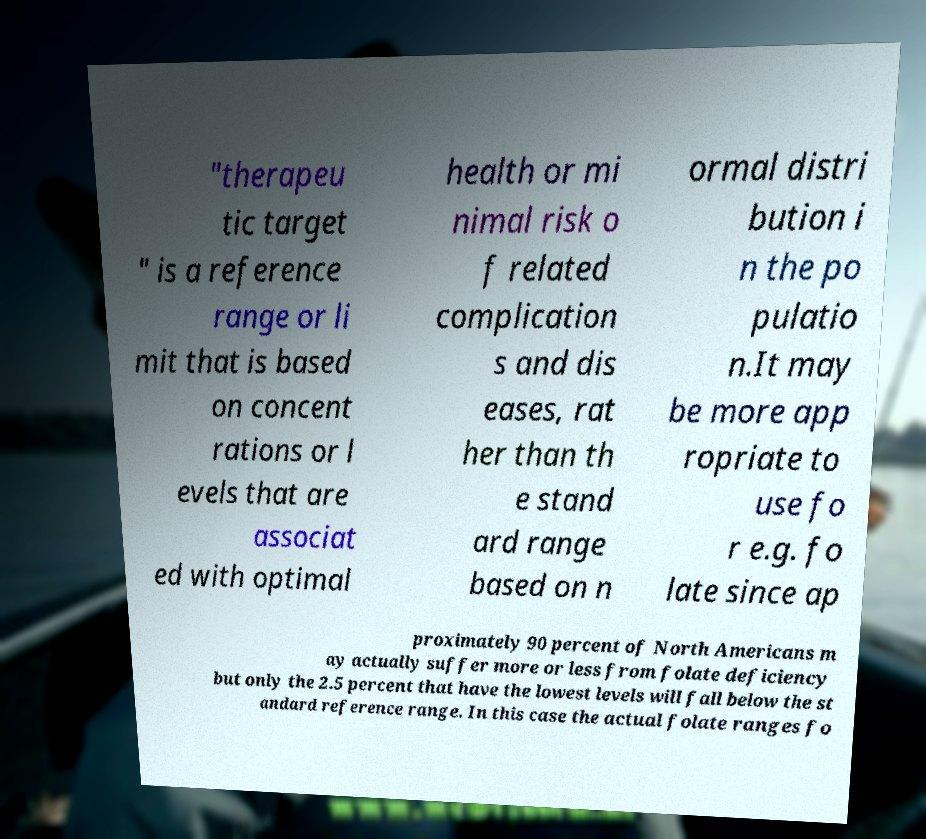Could you assist in decoding the text presented in this image and type it out clearly? "therapeu tic target " is a reference range or li mit that is based on concent rations or l evels that are associat ed with optimal health or mi nimal risk o f related complication s and dis eases, rat her than th e stand ard range based on n ormal distri bution i n the po pulatio n.It may be more app ropriate to use fo r e.g. fo late since ap proximately 90 percent of North Americans m ay actually suffer more or less from folate deficiency but only the 2.5 percent that have the lowest levels will fall below the st andard reference range. In this case the actual folate ranges fo 